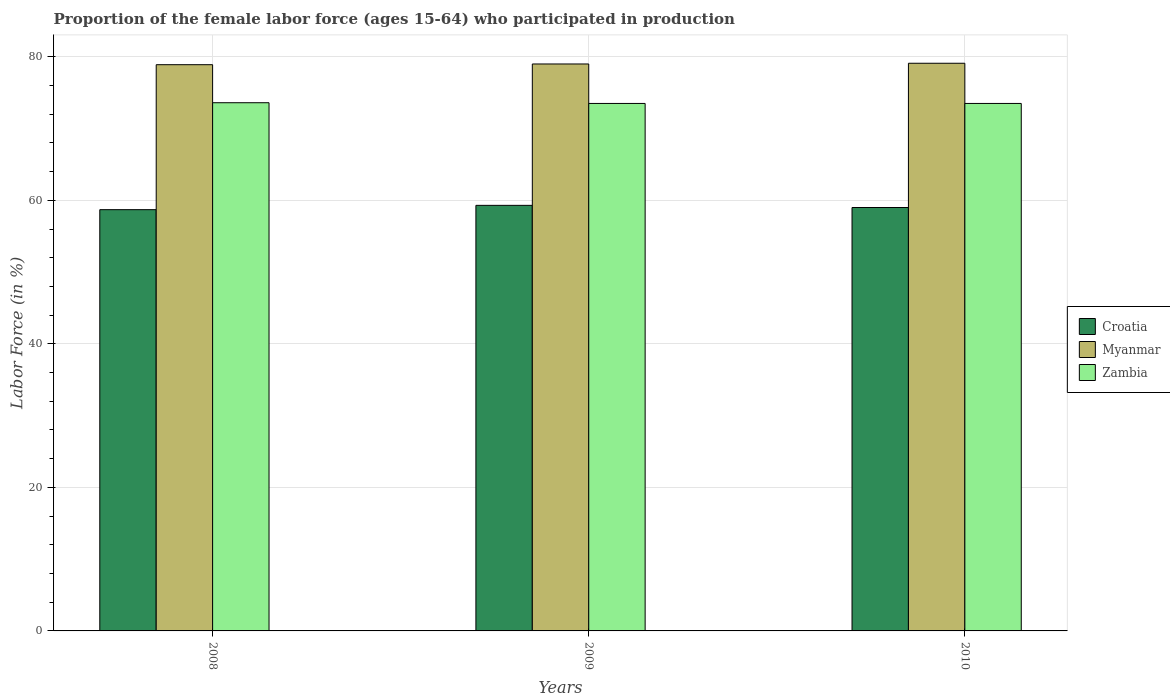Are the number of bars per tick equal to the number of legend labels?
Ensure brevity in your answer.  Yes. What is the proportion of the female labor force who participated in production in Croatia in 2008?
Ensure brevity in your answer.  58.7. Across all years, what is the maximum proportion of the female labor force who participated in production in Myanmar?
Ensure brevity in your answer.  79.1. Across all years, what is the minimum proportion of the female labor force who participated in production in Myanmar?
Provide a short and direct response. 78.9. What is the total proportion of the female labor force who participated in production in Myanmar in the graph?
Offer a terse response. 237. What is the difference between the proportion of the female labor force who participated in production in Croatia in 2009 and that in 2010?
Your answer should be compact. 0.3. What is the difference between the proportion of the female labor force who participated in production in Croatia in 2008 and the proportion of the female labor force who participated in production in Zambia in 2010?
Provide a short and direct response. -14.8. What is the average proportion of the female labor force who participated in production in Zambia per year?
Your answer should be very brief. 73.53. In the year 2010, what is the difference between the proportion of the female labor force who participated in production in Zambia and proportion of the female labor force who participated in production in Myanmar?
Ensure brevity in your answer.  -5.6. In how many years, is the proportion of the female labor force who participated in production in Myanmar greater than 32 %?
Offer a very short reply. 3. What is the ratio of the proportion of the female labor force who participated in production in Croatia in 2009 to that in 2010?
Ensure brevity in your answer.  1.01. Is the proportion of the female labor force who participated in production in Croatia in 2008 less than that in 2009?
Your answer should be very brief. Yes. What is the difference between the highest and the second highest proportion of the female labor force who participated in production in Myanmar?
Provide a succinct answer. 0.1. What is the difference between the highest and the lowest proportion of the female labor force who participated in production in Zambia?
Give a very brief answer. 0.1. In how many years, is the proportion of the female labor force who participated in production in Croatia greater than the average proportion of the female labor force who participated in production in Croatia taken over all years?
Provide a short and direct response. 1. What does the 2nd bar from the left in 2010 represents?
Your answer should be very brief. Myanmar. What does the 2nd bar from the right in 2008 represents?
Provide a short and direct response. Myanmar. Is it the case that in every year, the sum of the proportion of the female labor force who participated in production in Croatia and proportion of the female labor force who participated in production in Myanmar is greater than the proportion of the female labor force who participated in production in Zambia?
Give a very brief answer. Yes. How many bars are there?
Make the answer very short. 9. Are all the bars in the graph horizontal?
Your answer should be compact. No. Does the graph contain any zero values?
Your answer should be very brief. No. Where does the legend appear in the graph?
Keep it short and to the point. Center right. How many legend labels are there?
Your answer should be compact. 3. What is the title of the graph?
Give a very brief answer. Proportion of the female labor force (ages 15-64) who participated in production. Does "Japan" appear as one of the legend labels in the graph?
Give a very brief answer. No. What is the label or title of the X-axis?
Provide a short and direct response. Years. What is the Labor Force (in %) in Croatia in 2008?
Provide a succinct answer. 58.7. What is the Labor Force (in %) in Myanmar in 2008?
Make the answer very short. 78.9. What is the Labor Force (in %) of Zambia in 2008?
Offer a terse response. 73.6. What is the Labor Force (in %) of Croatia in 2009?
Ensure brevity in your answer.  59.3. What is the Labor Force (in %) of Myanmar in 2009?
Your response must be concise. 79. What is the Labor Force (in %) in Zambia in 2009?
Make the answer very short. 73.5. What is the Labor Force (in %) of Croatia in 2010?
Give a very brief answer. 59. What is the Labor Force (in %) of Myanmar in 2010?
Provide a succinct answer. 79.1. What is the Labor Force (in %) of Zambia in 2010?
Provide a short and direct response. 73.5. Across all years, what is the maximum Labor Force (in %) of Croatia?
Your answer should be very brief. 59.3. Across all years, what is the maximum Labor Force (in %) of Myanmar?
Your answer should be compact. 79.1. Across all years, what is the maximum Labor Force (in %) in Zambia?
Offer a terse response. 73.6. Across all years, what is the minimum Labor Force (in %) in Croatia?
Keep it short and to the point. 58.7. Across all years, what is the minimum Labor Force (in %) of Myanmar?
Provide a succinct answer. 78.9. Across all years, what is the minimum Labor Force (in %) of Zambia?
Your response must be concise. 73.5. What is the total Labor Force (in %) in Croatia in the graph?
Your response must be concise. 177. What is the total Labor Force (in %) in Myanmar in the graph?
Provide a short and direct response. 237. What is the total Labor Force (in %) of Zambia in the graph?
Keep it short and to the point. 220.6. What is the difference between the Labor Force (in %) in Croatia in 2008 and that in 2009?
Offer a very short reply. -0.6. What is the difference between the Labor Force (in %) of Myanmar in 2008 and that in 2009?
Give a very brief answer. -0.1. What is the difference between the Labor Force (in %) of Zambia in 2008 and that in 2009?
Offer a very short reply. 0.1. What is the difference between the Labor Force (in %) of Croatia in 2008 and that in 2010?
Make the answer very short. -0.3. What is the difference between the Labor Force (in %) in Myanmar in 2008 and that in 2010?
Your answer should be compact. -0.2. What is the difference between the Labor Force (in %) of Zambia in 2008 and that in 2010?
Your answer should be very brief. 0.1. What is the difference between the Labor Force (in %) in Croatia in 2009 and that in 2010?
Make the answer very short. 0.3. What is the difference between the Labor Force (in %) of Myanmar in 2009 and that in 2010?
Ensure brevity in your answer.  -0.1. What is the difference between the Labor Force (in %) of Zambia in 2009 and that in 2010?
Ensure brevity in your answer.  0. What is the difference between the Labor Force (in %) in Croatia in 2008 and the Labor Force (in %) in Myanmar in 2009?
Offer a very short reply. -20.3. What is the difference between the Labor Force (in %) of Croatia in 2008 and the Labor Force (in %) of Zambia in 2009?
Give a very brief answer. -14.8. What is the difference between the Labor Force (in %) in Croatia in 2008 and the Labor Force (in %) in Myanmar in 2010?
Offer a terse response. -20.4. What is the difference between the Labor Force (in %) of Croatia in 2008 and the Labor Force (in %) of Zambia in 2010?
Provide a succinct answer. -14.8. What is the difference between the Labor Force (in %) of Myanmar in 2008 and the Labor Force (in %) of Zambia in 2010?
Provide a short and direct response. 5.4. What is the difference between the Labor Force (in %) in Croatia in 2009 and the Labor Force (in %) in Myanmar in 2010?
Your response must be concise. -19.8. What is the difference between the Labor Force (in %) of Croatia in 2009 and the Labor Force (in %) of Zambia in 2010?
Offer a terse response. -14.2. What is the average Labor Force (in %) in Myanmar per year?
Your answer should be very brief. 79. What is the average Labor Force (in %) of Zambia per year?
Your answer should be compact. 73.53. In the year 2008, what is the difference between the Labor Force (in %) of Croatia and Labor Force (in %) of Myanmar?
Offer a terse response. -20.2. In the year 2008, what is the difference between the Labor Force (in %) in Croatia and Labor Force (in %) in Zambia?
Give a very brief answer. -14.9. In the year 2008, what is the difference between the Labor Force (in %) in Myanmar and Labor Force (in %) in Zambia?
Provide a short and direct response. 5.3. In the year 2009, what is the difference between the Labor Force (in %) of Croatia and Labor Force (in %) of Myanmar?
Ensure brevity in your answer.  -19.7. In the year 2010, what is the difference between the Labor Force (in %) in Croatia and Labor Force (in %) in Myanmar?
Offer a terse response. -20.1. What is the ratio of the Labor Force (in %) of Croatia in 2008 to that in 2009?
Give a very brief answer. 0.99. What is the ratio of the Labor Force (in %) of Zambia in 2008 to that in 2009?
Provide a succinct answer. 1. What is the ratio of the Labor Force (in %) of Zambia in 2008 to that in 2010?
Provide a short and direct response. 1. What is the ratio of the Labor Force (in %) of Myanmar in 2009 to that in 2010?
Make the answer very short. 1. What is the ratio of the Labor Force (in %) in Zambia in 2009 to that in 2010?
Provide a short and direct response. 1. What is the difference between the highest and the second highest Labor Force (in %) of Myanmar?
Provide a short and direct response. 0.1. What is the difference between the highest and the lowest Labor Force (in %) of Myanmar?
Keep it short and to the point. 0.2. 